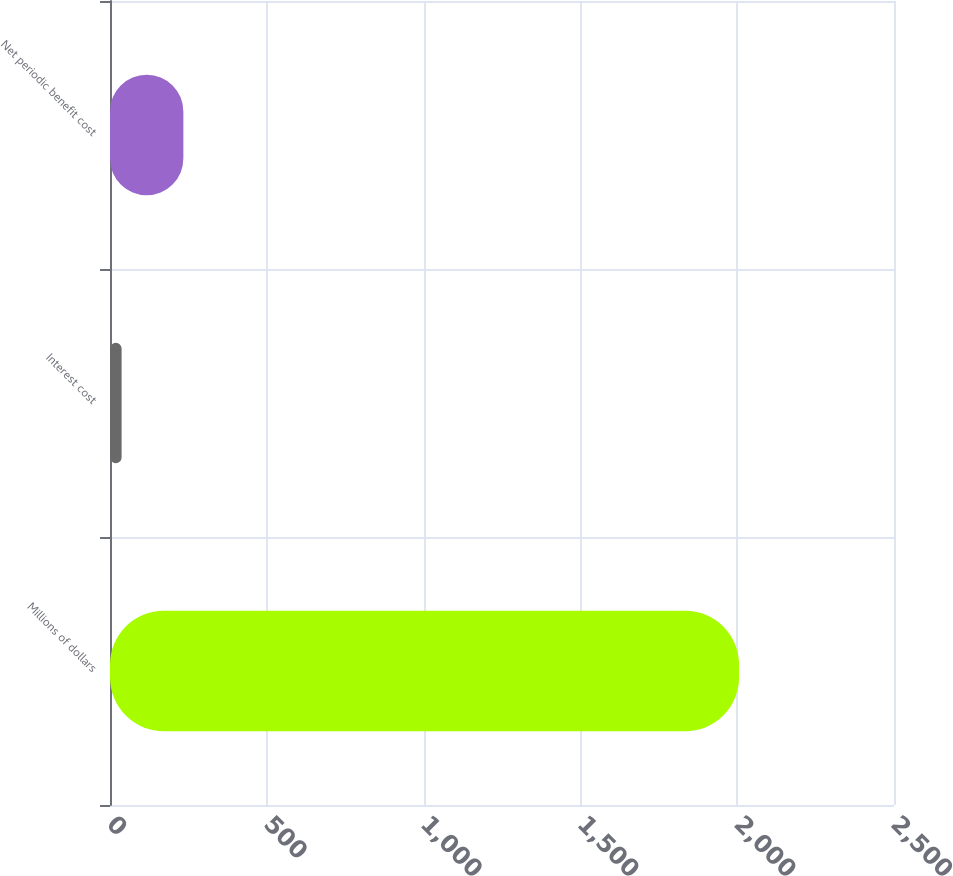<chart> <loc_0><loc_0><loc_500><loc_500><bar_chart><fcel>Millions of dollars<fcel>Interest cost<fcel>Net periodic benefit cost<nl><fcel>2006<fcel>37<fcel>233.9<nl></chart> 